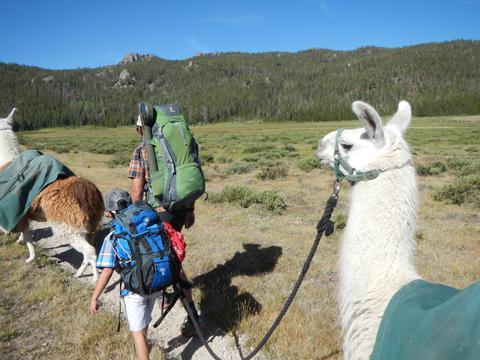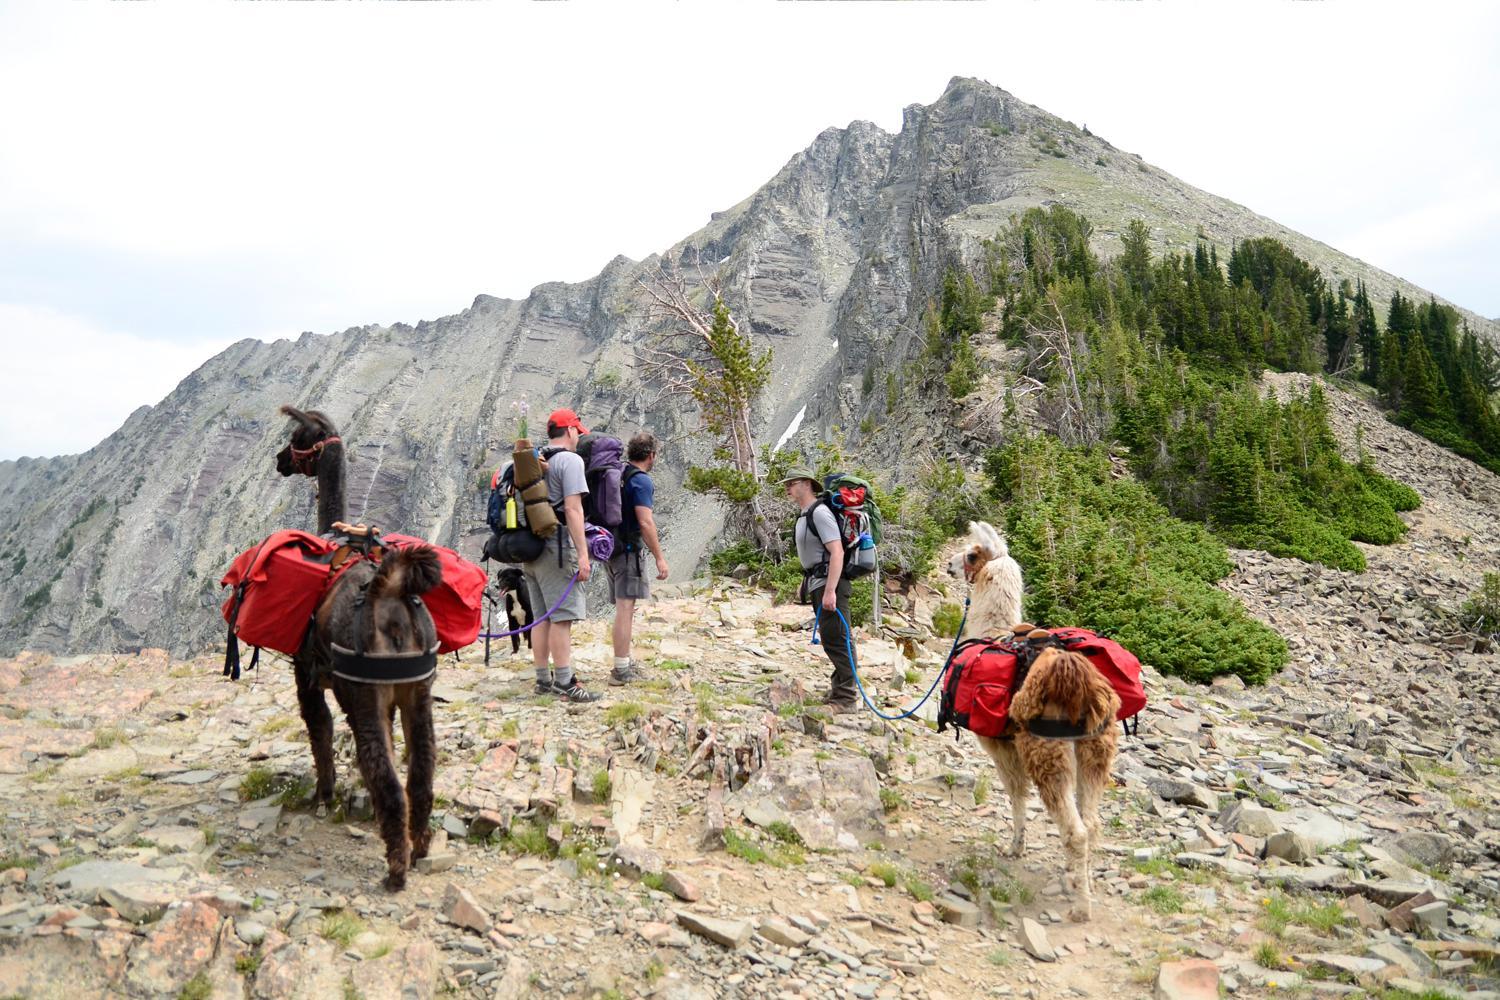The first image is the image on the left, the second image is the image on the right. Given the left and right images, does the statement "The right image shows multiple people standing near multiple llamas wearing packs and facing mountain peaks." hold true? Answer yes or no. Yes. The first image is the image on the left, the second image is the image on the right. Considering the images on both sides, is "The llamas in the right image are carrying packs." valid? Answer yes or no. Yes. 